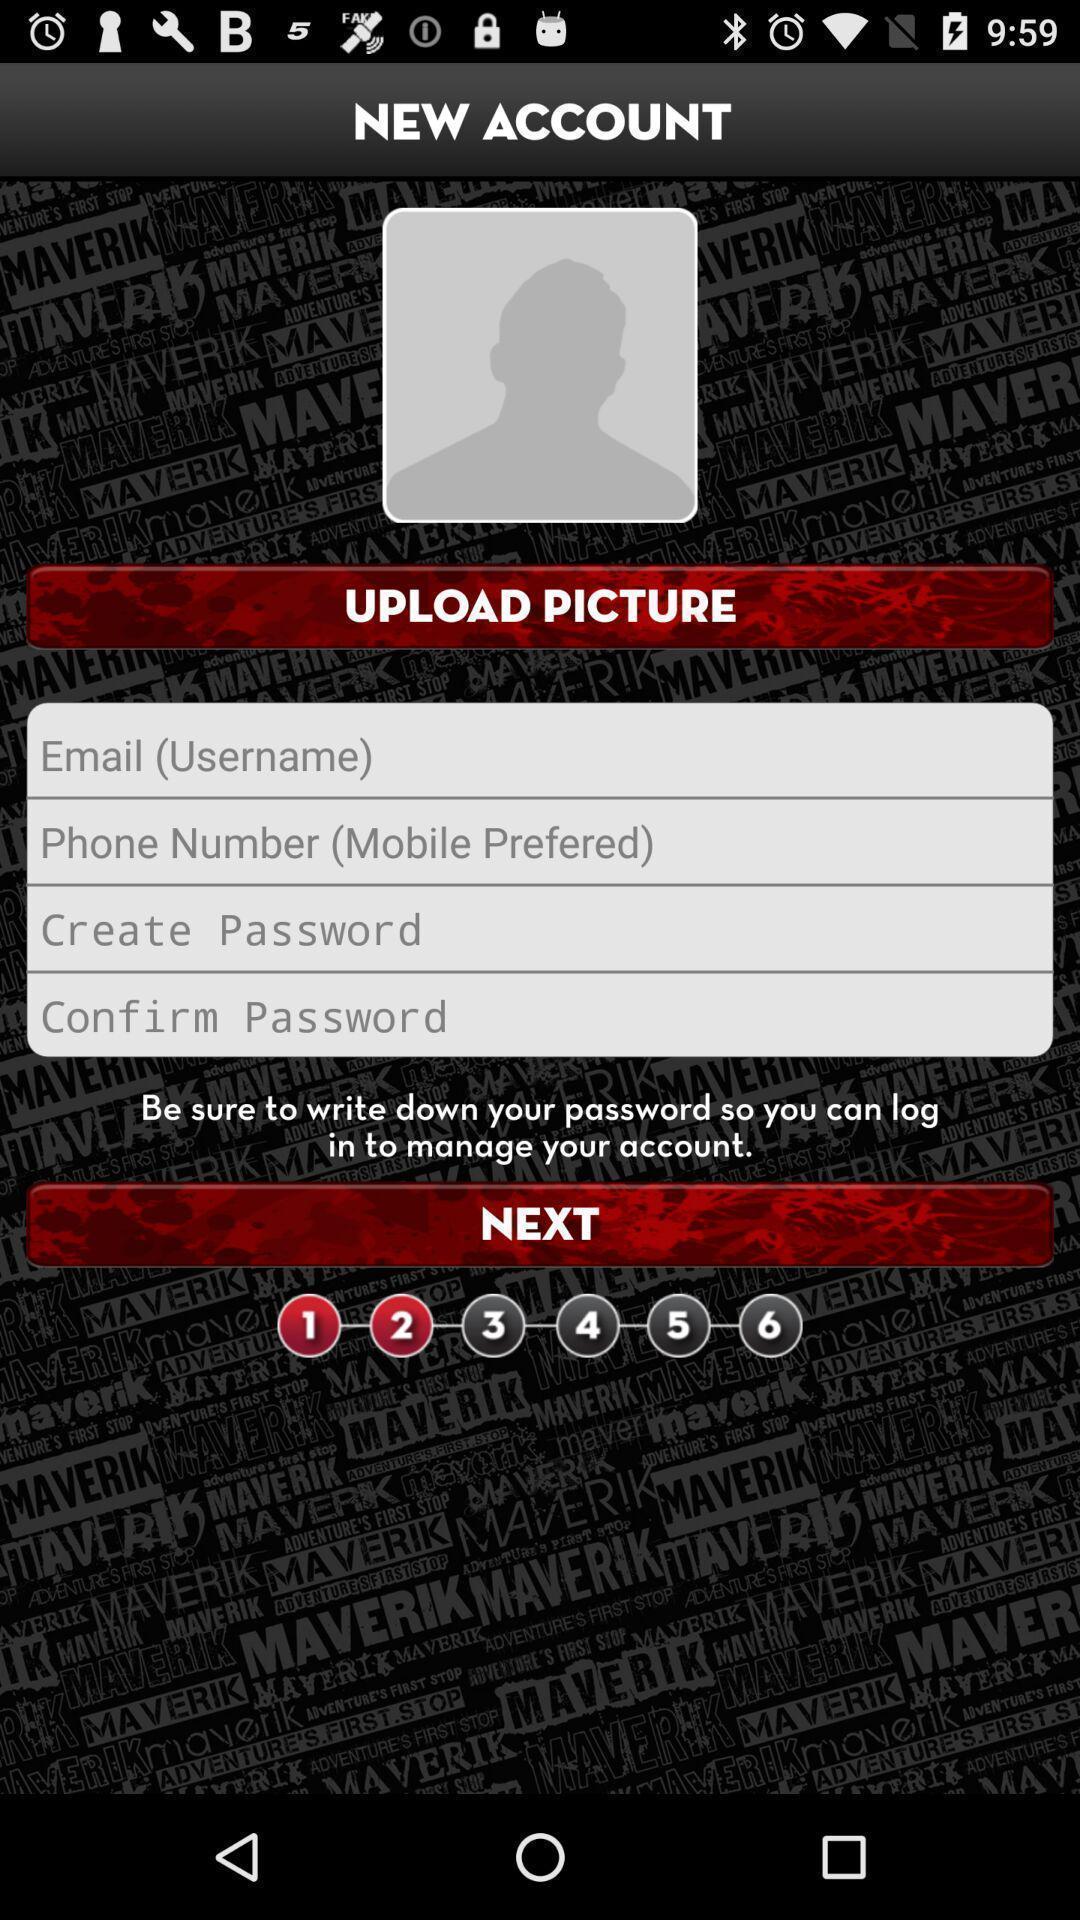Provide a detailed account of this screenshot. Sign up page of an adventure app. 